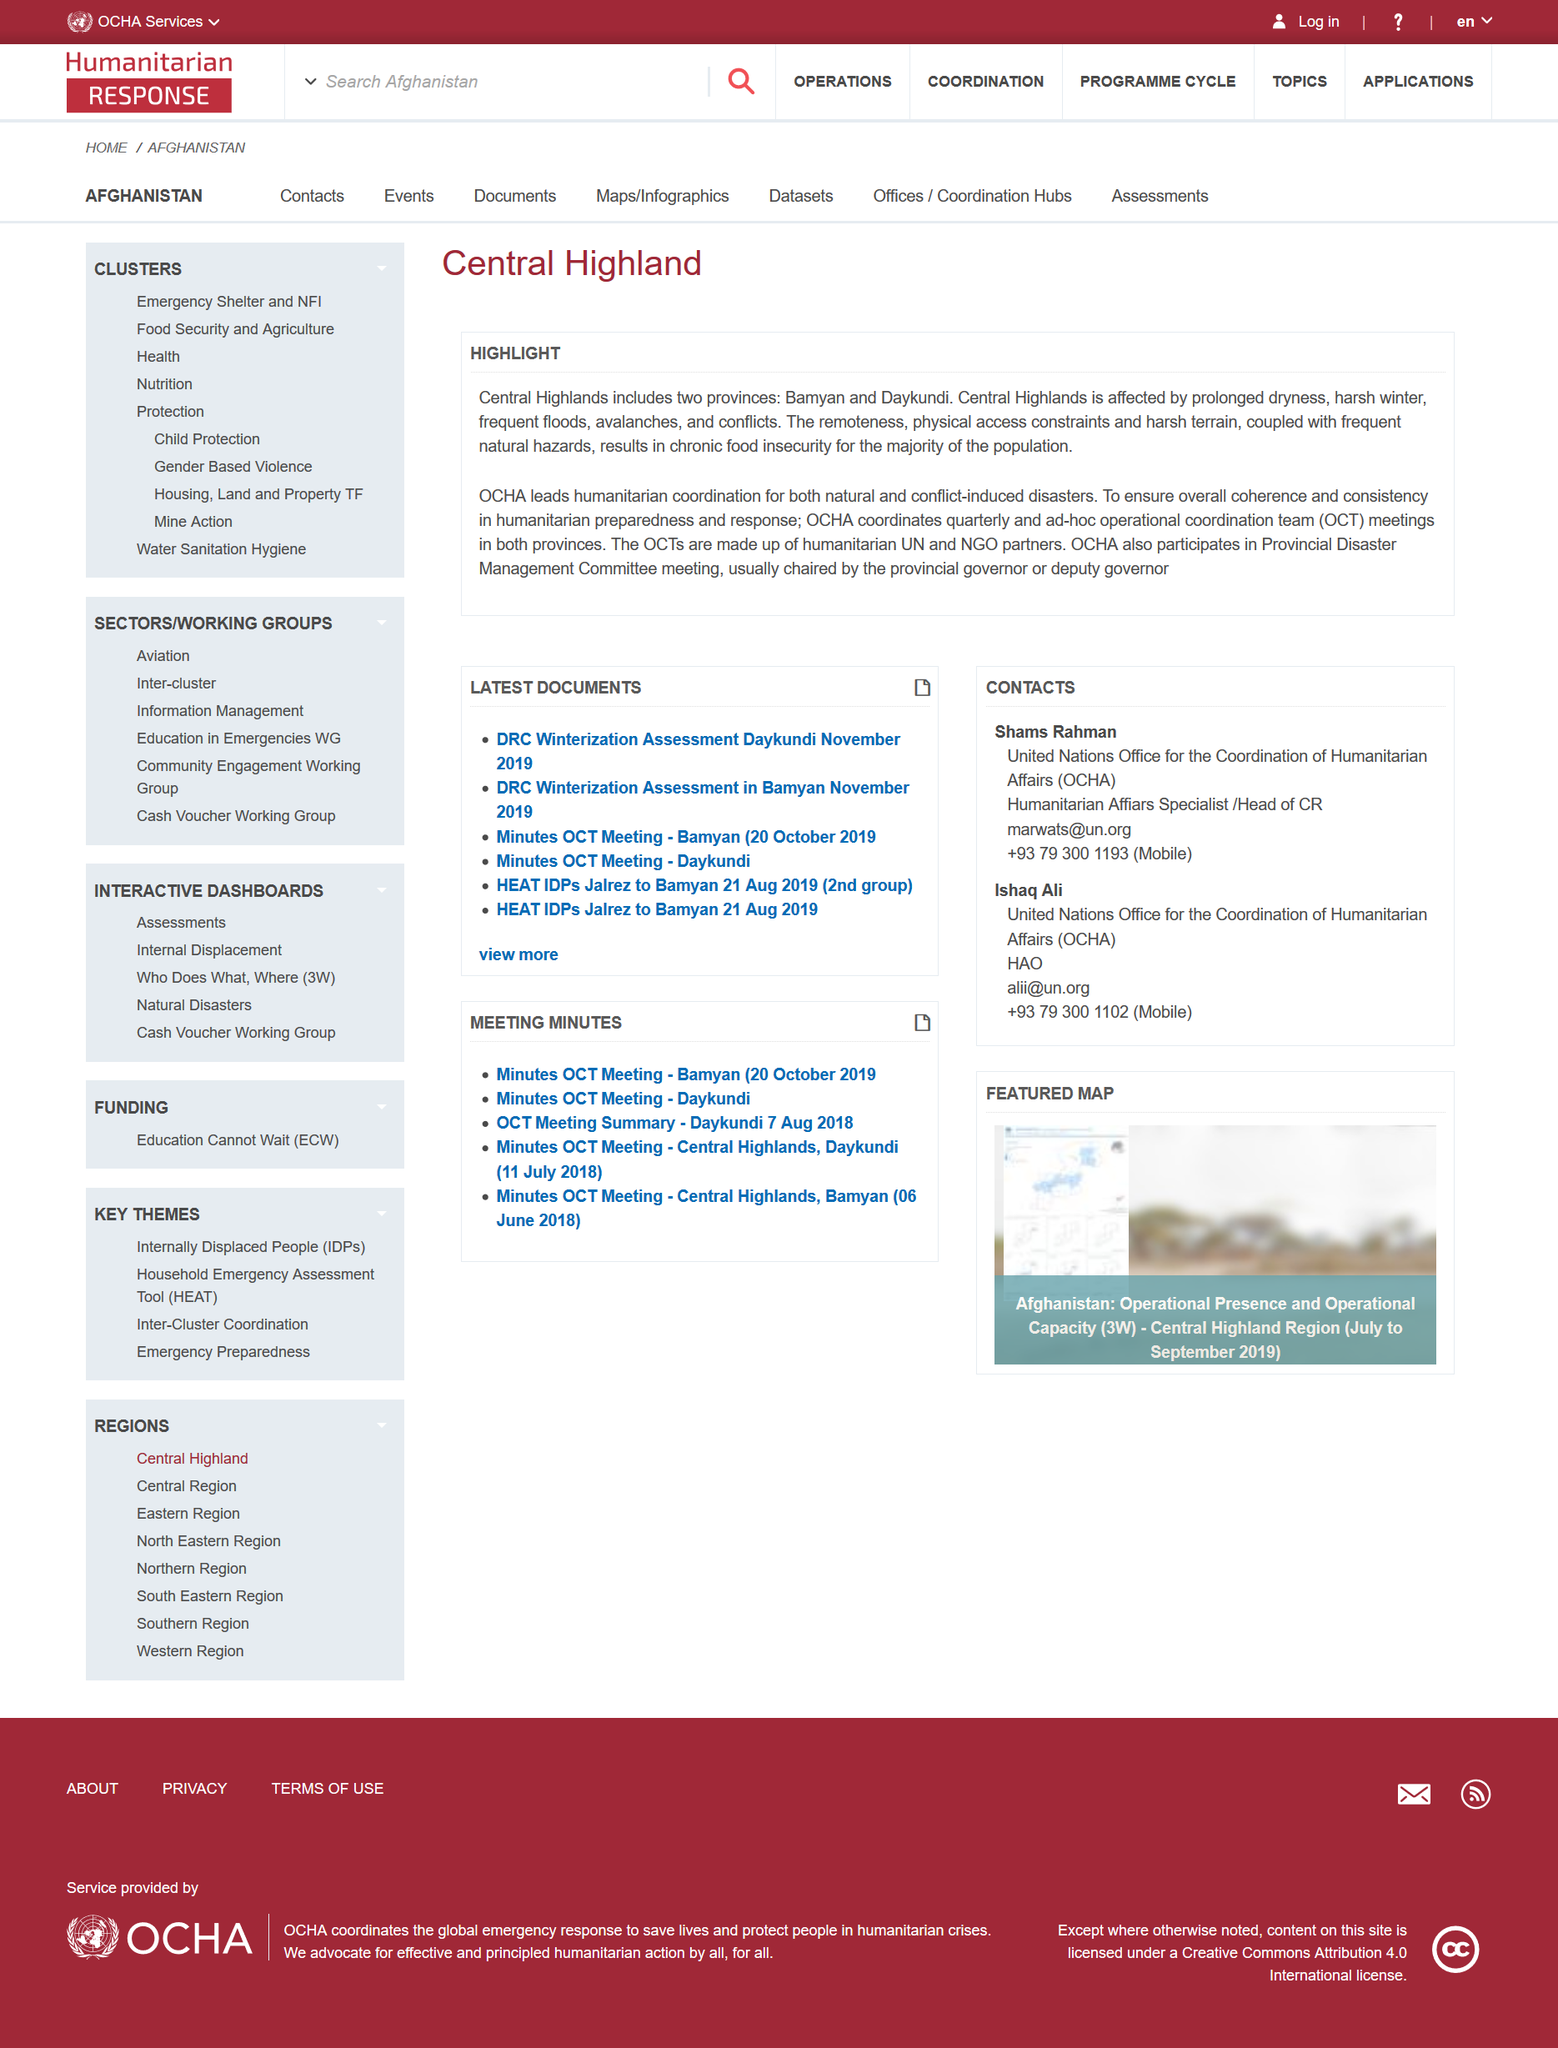Mention a couple of crucial points in this snapshot. The Office for the Coordination of Humanitarian Affairs (OCHA) leads the humanitarian coordination for both natural and conflict-induced disasters in the Central Highlands. The provinces Bamyan and Daykundi are located in the Central Highlands. The Central Highlands suffer from prolonged dryness, harsh winters, frequent floods, avalanches, and conflicts as detailed in the article on "Central Highlands. 